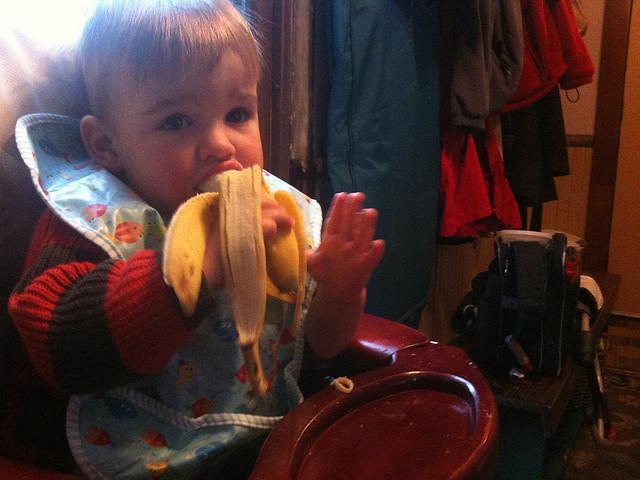What animal is depicted on the child's bib?
Give a very brief answer. Fish. What is the boy holding in his right hand?
Concise answer only. Banana. What fruit is the child eating?
Quick response, please. Banana. Is this a vegan meal?
Write a very short answer. Yes. What food does the child have on his plate?
Answer briefly. Banana. Are there shoes on the floor?
Keep it brief. No. Is the peeling still attached to the banana?
Concise answer only. Yes. 